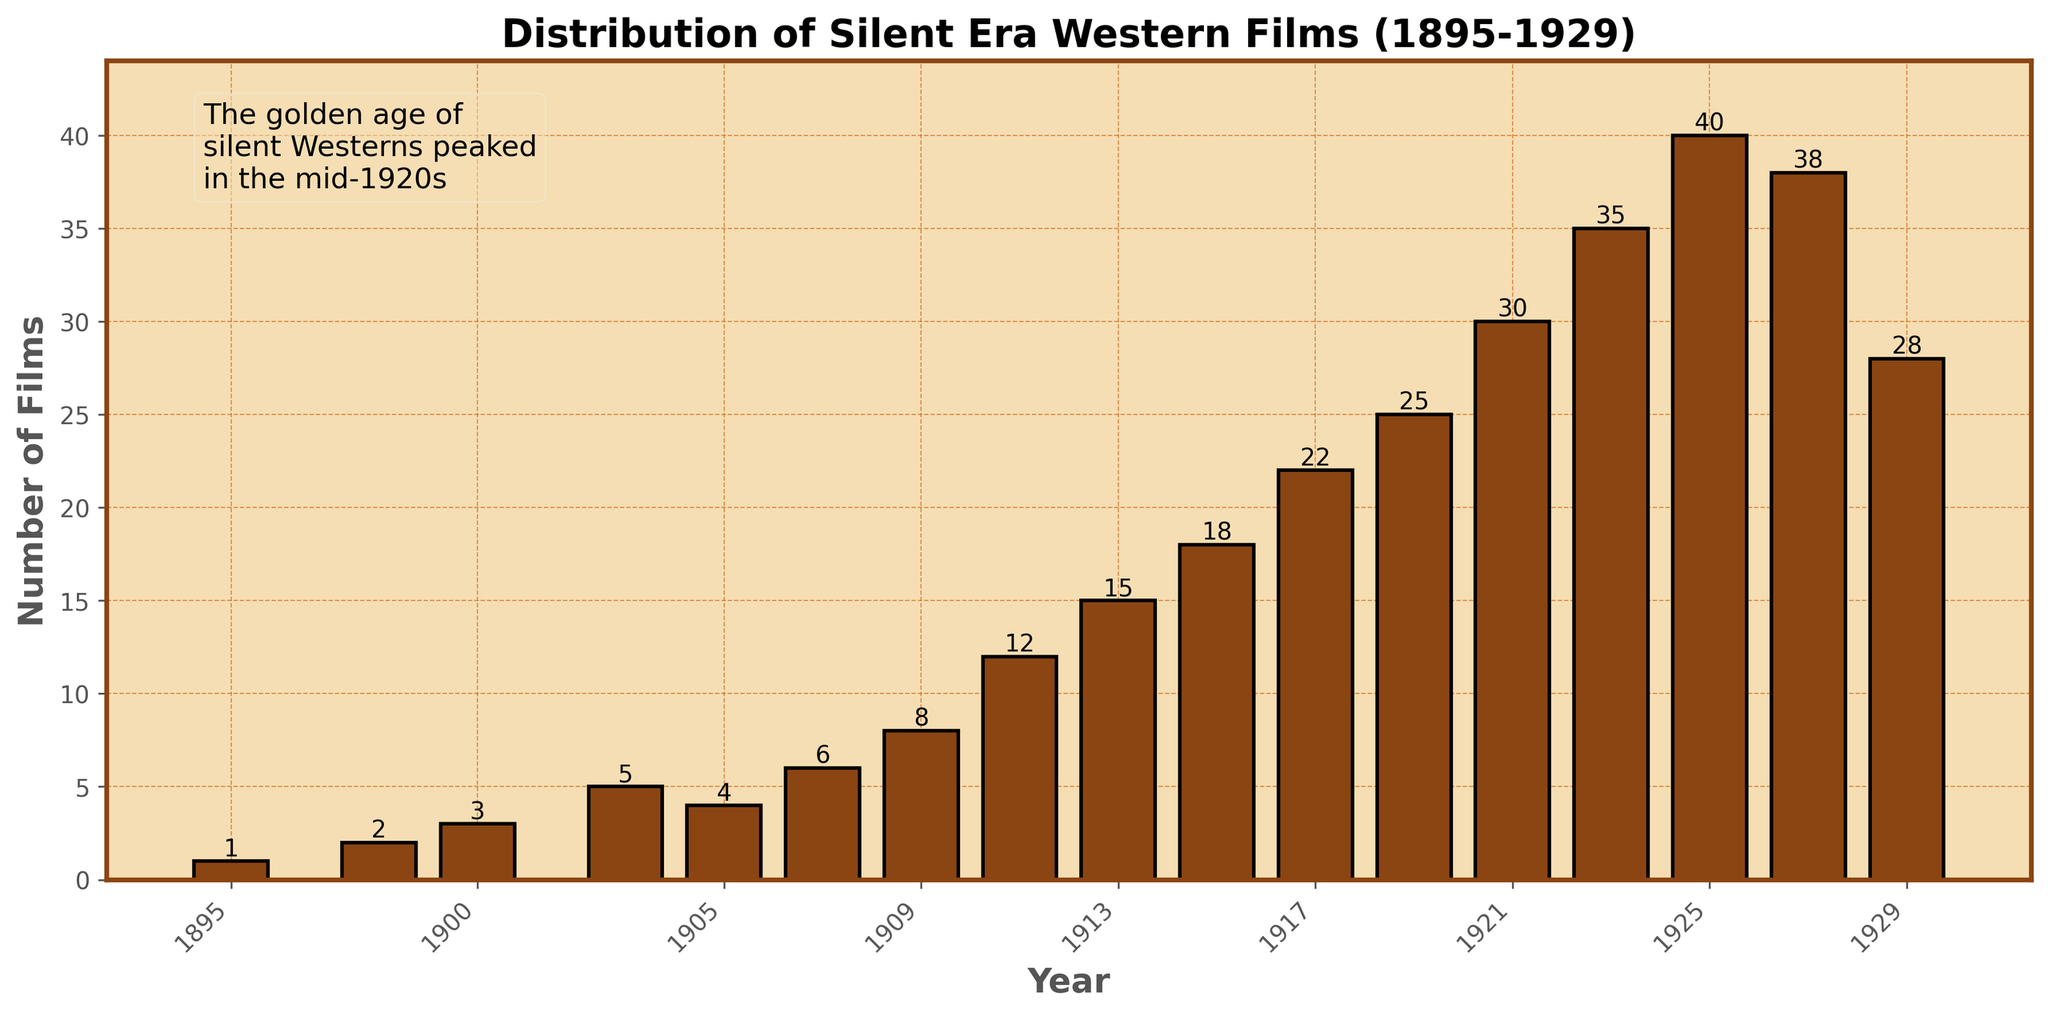Which year had the peak number of silent Western films? The tallest bar in the chart corresponds to the year with the highest number of films. The peak is at 1925.
Answer: 1925 Which year had fewer films: 1911 or 1913? By how many? The bar for 1911 is shorter than for 1913. 1911 had 12 films, and 1913 had 15 films. The difference is 15 - 12 = 3 films.
Answer: 1911, by 3 films How many films were released in total during the peak year and the year immediately after it? The peak year is 1925 with 40 films, and 1927 had 38 films. The total is 40 + 38 = 78 films.
Answer: 78 films In which year did the number of films first exceed 20? The bar first exceeds 20 films in 1917.
Answer: 1917 What is the average number of films released per year from 1895 to 1929? Sum all the values from 1895 to 1929, then divide by the number of years (17 years). The sum is 322 films, so the average is 322 / 17 ≈ 18.94 films per year.
Answer: ~18.94 films per year Which year saw a decrease in the number of films compared to the previous year first? Compare consecutive bars. The first decrease occurs between 1927 (38 films) and 1929 (28 films).
Answer: 1929 Compare the total number of films released in the 1910s with the total released in the 1920s. Which decade released more films, and by how many? Sum the films from 1910s: 12 (1911) + 15 (1913) + 18 (1915) + 22 (1917) + 25 (1919) = 92. Sum the films from 1920s: 30 (1921) + 35 (1923) + 40 (1925) + 38 (1927) + 28 (1929) = 171. The difference is 171 - 92 = 79 films.
Answer: 1920s, by 79 films What is the difference between the number of films released in 1900 and 1919? The bar for 1900 indicates 3 films, and for 1919, it indicates 25 films. The difference is 25 - 3 = 22 films.
Answer: 22 films How many films were released in years where the number of films is less than 10? Sum films from years with less than 10 films: 1 (1895) + 2 (1898) + 3 (1900) + 5 (1903) + 4 (1905) + 6 (1907) + 8 (1909) = 29 films.
Answer: 29 films By how much did the number of films increase from 1915 to 1921? Films in 1915 were 18 and 1921 were 30. The increase is 30 - 18 = 12 films.
Answer: 12 films 